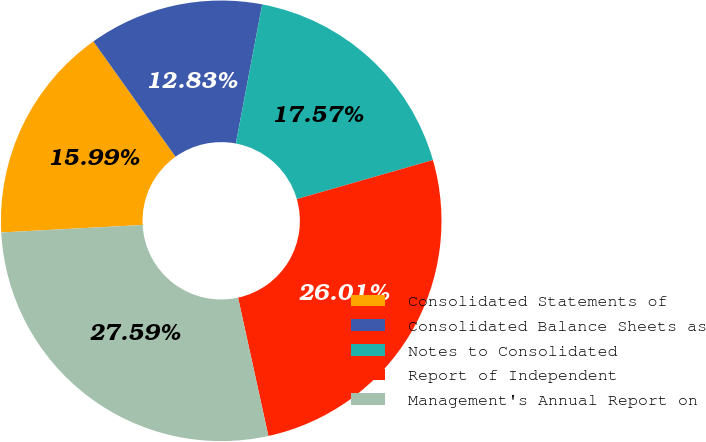Convert chart. <chart><loc_0><loc_0><loc_500><loc_500><pie_chart><fcel>Consolidated Statements of<fcel>Consolidated Balance Sheets as<fcel>Notes to Consolidated<fcel>Report of Independent<fcel>Management's Annual Report on<nl><fcel>15.99%<fcel>12.83%<fcel>17.57%<fcel>26.01%<fcel>27.59%<nl></chart> 